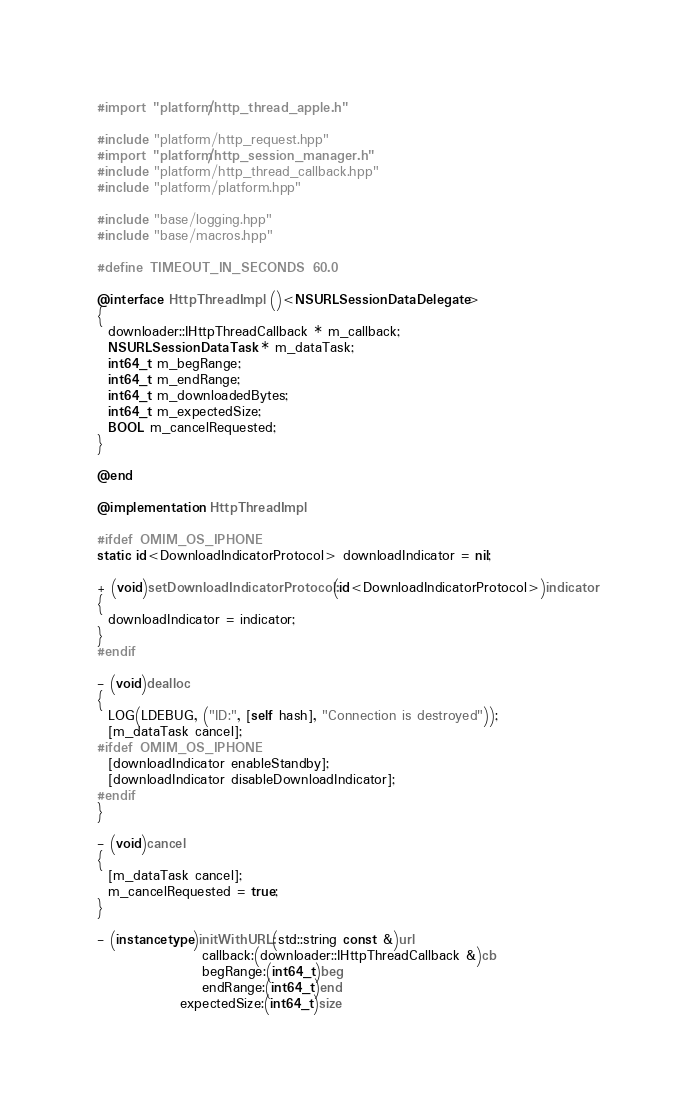Convert code to text. <code><loc_0><loc_0><loc_500><loc_500><_ObjectiveC_>#import "platform/http_thread_apple.h"

#include "platform/http_request.hpp"
#import "platform/http_session_manager.h"
#include "platform/http_thread_callback.hpp"
#include "platform/platform.hpp"

#include "base/logging.hpp"
#include "base/macros.hpp"

#define TIMEOUT_IN_SECONDS 60.0

@interface HttpThreadImpl ()<NSURLSessionDataDelegate>
{
  downloader::IHttpThreadCallback * m_callback;
  NSURLSessionDataTask * m_dataTask;
  int64_t m_begRange;
  int64_t m_endRange;
  int64_t m_downloadedBytes;
  int64_t m_expectedSize;
  BOOL m_cancelRequested;
}

@end

@implementation HttpThreadImpl

#ifdef OMIM_OS_IPHONE
static id<DownloadIndicatorProtocol> downloadIndicator = nil;

+ (void)setDownloadIndicatorProtocol:(id<DownloadIndicatorProtocol>)indicator
{
  downloadIndicator = indicator;
}
#endif

- (void)dealloc
{
  LOG(LDEBUG, ("ID:", [self hash], "Connection is destroyed"));
  [m_dataTask cancel];
#ifdef OMIM_OS_IPHONE
  [downloadIndicator enableStandby];
  [downloadIndicator disableDownloadIndicator];
#endif
}

- (void)cancel
{
  [m_dataTask cancel];
  m_cancelRequested = true;
}

- (instancetype)initWithURL:(std::string const &)url
                   callback:(downloader::IHttpThreadCallback &)cb
                   begRange:(int64_t)beg
                   endRange:(int64_t)end
               expectedSize:(int64_t)size</code> 